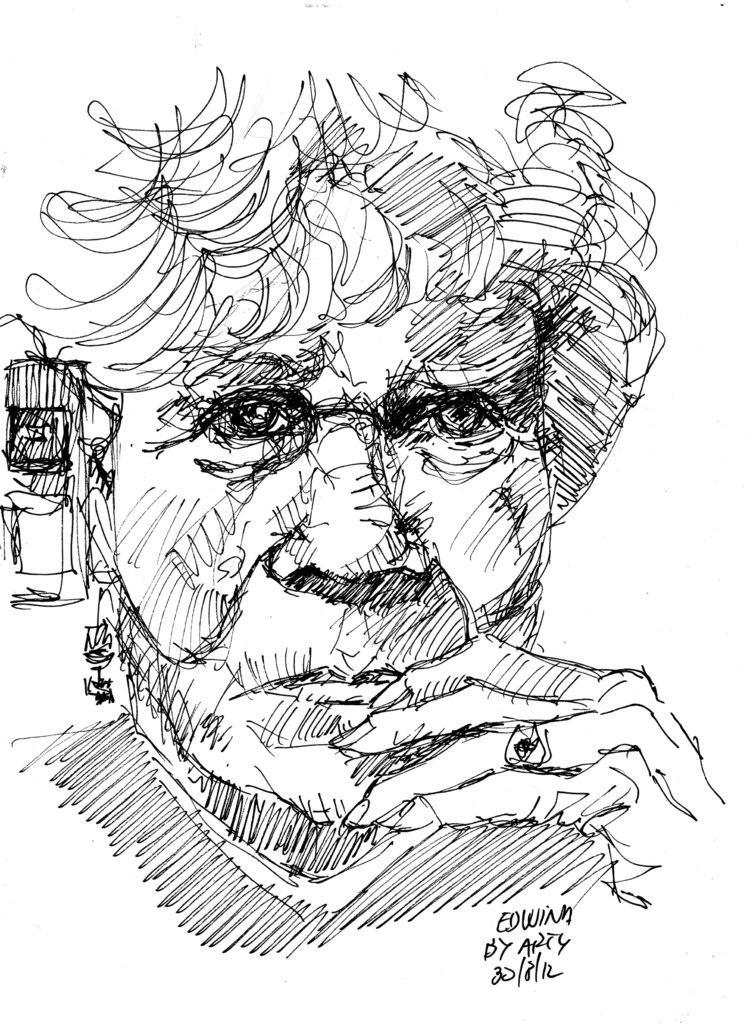Can you describe this image briefly? In this picture I can see a fart, looks like a woman and I can see text at the bottom right corner of the picture. 